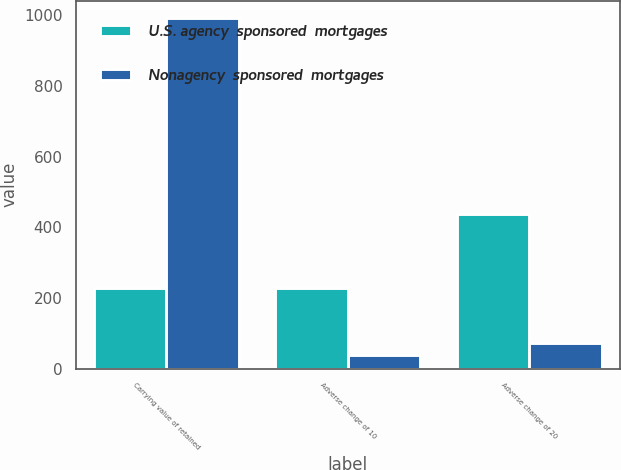Convert chart to OTSL. <chart><loc_0><loc_0><loc_500><loc_500><stacked_bar_chart><ecel><fcel>Carrying value of retained<fcel>Adverse change of 10<fcel>Adverse change of 20<nl><fcel>U.S. agency  sponsored  mortgages<fcel>227<fcel>227<fcel>439<nl><fcel>Nonagency  sponsored  mortgages<fcel>992<fcel>38<fcel>74<nl></chart> 